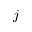<formula> <loc_0><loc_0><loc_500><loc_500>j</formula> 